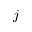<formula> <loc_0><loc_0><loc_500><loc_500>j</formula> 